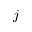<formula> <loc_0><loc_0><loc_500><loc_500>j</formula> 